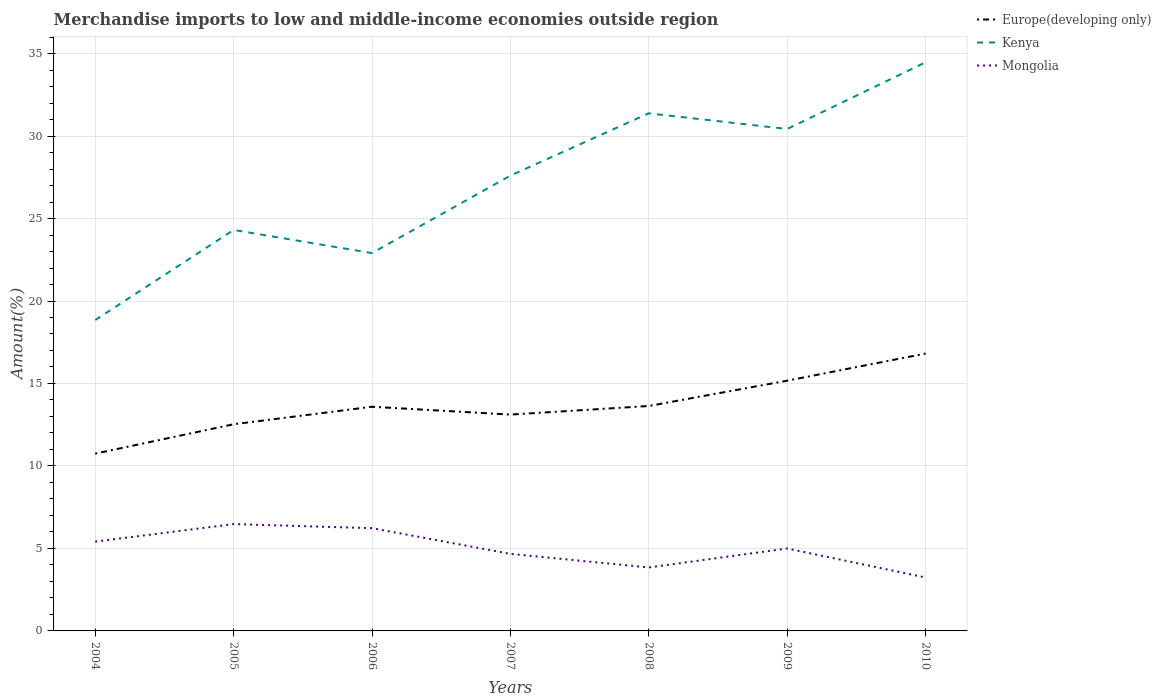How many different coloured lines are there?
Offer a very short reply. 3. Does the line corresponding to Europe(developing only) intersect with the line corresponding to Mongolia?
Keep it short and to the point. No. Is the number of lines equal to the number of legend labels?
Keep it short and to the point. Yes. Across all years, what is the maximum percentage of amount earned from merchandise imports in Europe(developing only)?
Your response must be concise. 10.75. What is the total percentage of amount earned from merchandise imports in Kenya in the graph?
Give a very brief answer. -2.83. What is the difference between the highest and the second highest percentage of amount earned from merchandise imports in Kenya?
Your answer should be very brief. 15.62. Is the percentage of amount earned from merchandise imports in Mongolia strictly greater than the percentage of amount earned from merchandise imports in Kenya over the years?
Offer a terse response. Yes. How many lines are there?
Make the answer very short. 3. How many legend labels are there?
Offer a very short reply. 3. How are the legend labels stacked?
Your answer should be very brief. Vertical. What is the title of the graph?
Offer a very short reply. Merchandise imports to low and middle-income economies outside region. What is the label or title of the X-axis?
Give a very brief answer. Years. What is the label or title of the Y-axis?
Offer a terse response. Amount(%). What is the Amount(%) of Europe(developing only) in 2004?
Your answer should be very brief. 10.75. What is the Amount(%) in Kenya in 2004?
Your response must be concise. 18.85. What is the Amount(%) of Mongolia in 2004?
Ensure brevity in your answer.  5.41. What is the Amount(%) in Europe(developing only) in 2005?
Give a very brief answer. 12.53. What is the Amount(%) of Kenya in 2005?
Your response must be concise. 24.31. What is the Amount(%) in Mongolia in 2005?
Your answer should be very brief. 6.48. What is the Amount(%) of Europe(developing only) in 2006?
Provide a short and direct response. 13.59. What is the Amount(%) of Kenya in 2006?
Give a very brief answer. 22.91. What is the Amount(%) of Mongolia in 2006?
Make the answer very short. 6.23. What is the Amount(%) in Europe(developing only) in 2007?
Offer a terse response. 13.11. What is the Amount(%) of Kenya in 2007?
Ensure brevity in your answer.  27.6. What is the Amount(%) of Mongolia in 2007?
Your answer should be very brief. 4.67. What is the Amount(%) in Europe(developing only) in 2008?
Offer a terse response. 13.64. What is the Amount(%) in Kenya in 2008?
Your response must be concise. 31.38. What is the Amount(%) in Mongolia in 2008?
Your answer should be very brief. 3.85. What is the Amount(%) in Europe(developing only) in 2009?
Give a very brief answer. 15.17. What is the Amount(%) of Kenya in 2009?
Offer a terse response. 30.43. What is the Amount(%) of Mongolia in 2009?
Give a very brief answer. 5. What is the Amount(%) in Europe(developing only) in 2010?
Provide a short and direct response. 16.81. What is the Amount(%) of Kenya in 2010?
Give a very brief answer. 34.47. What is the Amount(%) in Mongolia in 2010?
Give a very brief answer. 3.24. Across all years, what is the maximum Amount(%) of Europe(developing only)?
Make the answer very short. 16.81. Across all years, what is the maximum Amount(%) of Kenya?
Provide a succinct answer. 34.47. Across all years, what is the maximum Amount(%) of Mongolia?
Make the answer very short. 6.48. Across all years, what is the minimum Amount(%) in Europe(developing only)?
Your response must be concise. 10.75. Across all years, what is the minimum Amount(%) of Kenya?
Give a very brief answer. 18.85. Across all years, what is the minimum Amount(%) in Mongolia?
Your response must be concise. 3.24. What is the total Amount(%) of Europe(developing only) in the graph?
Provide a succinct answer. 95.6. What is the total Amount(%) in Kenya in the graph?
Keep it short and to the point. 189.93. What is the total Amount(%) of Mongolia in the graph?
Give a very brief answer. 34.88. What is the difference between the Amount(%) of Europe(developing only) in 2004 and that in 2005?
Ensure brevity in your answer.  -1.78. What is the difference between the Amount(%) in Kenya in 2004 and that in 2005?
Provide a succinct answer. -5.46. What is the difference between the Amount(%) in Mongolia in 2004 and that in 2005?
Your answer should be compact. -1.06. What is the difference between the Amount(%) of Europe(developing only) in 2004 and that in 2006?
Give a very brief answer. -2.84. What is the difference between the Amount(%) of Kenya in 2004 and that in 2006?
Give a very brief answer. -4.06. What is the difference between the Amount(%) in Mongolia in 2004 and that in 2006?
Ensure brevity in your answer.  -0.82. What is the difference between the Amount(%) of Europe(developing only) in 2004 and that in 2007?
Keep it short and to the point. -2.37. What is the difference between the Amount(%) of Kenya in 2004 and that in 2007?
Provide a succinct answer. -8.76. What is the difference between the Amount(%) in Mongolia in 2004 and that in 2007?
Your answer should be very brief. 0.74. What is the difference between the Amount(%) in Europe(developing only) in 2004 and that in 2008?
Provide a short and direct response. -2.89. What is the difference between the Amount(%) of Kenya in 2004 and that in 2008?
Your answer should be compact. -12.53. What is the difference between the Amount(%) of Mongolia in 2004 and that in 2008?
Ensure brevity in your answer.  1.57. What is the difference between the Amount(%) in Europe(developing only) in 2004 and that in 2009?
Your response must be concise. -4.42. What is the difference between the Amount(%) in Kenya in 2004 and that in 2009?
Ensure brevity in your answer.  -11.58. What is the difference between the Amount(%) in Mongolia in 2004 and that in 2009?
Keep it short and to the point. 0.42. What is the difference between the Amount(%) in Europe(developing only) in 2004 and that in 2010?
Provide a succinct answer. -6.07. What is the difference between the Amount(%) of Kenya in 2004 and that in 2010?
Offer a very short reply. -15.62. What is the difference between the Amount(%) of Mongolia in 2004 and that in 2010?
Provide a short and direct response. 2.18. What is the difference between the Amount(%) in Europe(developing only) in 2005 and that in 2006?
Make the answer very short. -1.06. What is the difference between the Amount(%) in Kenya in 2005 and that in 2006?
Offer a very short reply. 1.4. What is the difference between the Amount(%) of Mongolia in 2005 and that in 2006?
Ensure brevity in your answer.  0.25. What is the difference between the Amount(%) of Europe(developing only) in 2005 and that in 2007?
Your answer should be very brief. -0.59. What is the difference between the Amount(%) in Kenya in 2005 and that in 2007?
Give a very brief answer. -3.3. What is the difference between the Amount(%) of Mongolia in 2005 and that in 2007?
Make the answer very short. 1.81. What is the difference between the Amount(%) of Europe(developing only) in 2005 and that in 2008?
Your answer should be very brief. -1.11. What is the difference between the Amount(%) of Kenya in 2005 and that in 2008?
Provide a short and direct response. -7.07. What is the difference between the Amount(%) in Mongolia in 2005 and that in 2008?
Provide a short and direct response. 2.63. What is the difference between the Amount(%) in Europe(developing only) in 2005 and that in 2009?
Your response must be concise. -2.64. What is the difference between the Amount(%) of Kenya in 2005 and that in 2009?
Your answer should be compact. -6.12. What is the difference between the Amount(%) of Mongolia in 2005 and that in 2009?
Your answer should be compact. 1.48. What is the difference between the Amount(%) in Europe(developing only) in 2005 and that in 2010?
Make the answer very short. -4.29. What is the difference between the Amount(%) in Kenya in 2005 and that in 2010?
Ensure brevity in your answer.  -10.16. What is the difference between the Amount(%) of Mongolia in 2005 and that in 2010?
Keep it short and to the point. 3.24. What is the difference between the Amount(%) of Europe(developing only) in 2006 and that in 2007?
Provide a short and direct response. 0.47. What is the difference between the Amount(%) of Kenya in 2006 and that in 2007?
Provide a succinct answer. -4.7. What is the difference between the Amount(%) of Mongolia in 2006 and that in 2007?
Ensure brevity in your answer.  1.56. What is the difference between the Amount(%) of Europe(developing only) in 2006 and that in 2008?
Ensure brevity in your answer.  -0.05. What is the difference between the Amount(%) of Kenya in 2006 and that in 2008?
Make the answer very short. -8.47. What is the difference between the Amount(%) in Mongolia in 2006 and that in 2008?
Your answer should be compact. 2.38. What is the difference between the Amount(%) of Europe(developing only) in 2006 and that in 2009?
Your response must be concise. -1.58. What is the difference between the Amount(%) in Kenya in 2006 and that in 2009?
Offer a terse response. -7.52. What is the difference between the Amount(%) of Mongolia in 2006 and that in 2009?
Your response must be concise. 1.23. What is the difference between the Amount(%) of Europe(developing only) in 2006 and that in 2010?
Your answer should be very brief. -3.22. What is the difference between the Amount(%) in Kenya in 2006 and that in 2010?
Ensure brevity in your answer.  -11.56. What is the difference between the Amount(%) in Mongolia in 2006 and that in 2010?
Provide a short and direct response. 2.99. What is the difference between the Amount(%) of Europe(developing only) in 2007 and that in 2008?
Offer a terse response. -0.52. What is the difference between the Amount(%) of Kenya in 2007 and that in 2008?
Your answer should be very brief. -3.78. What is the difference between the Amount(%) of Mongolia in 2007 and that in 2008?
Provide a succinct answer. 0.82. What is the difference between the Amount(%) of Europe(developing only) in 2007 and that in 2009?
Give a very brief answer. -2.06. What is the difference between the Amount(%) of Kenya in 2007 and that in 2009?
Your answer should be very brief. -2.83. What is the difference between the Amount(%) of Mongolia in 2007 and that in 2009?
Your answer should be very brief. -0.33. What is the difference between the Amount(%) of Europe(developing only) in 2007 and that in 2010?
Offer a very short reply. -3.7. What is the difference between the Amount(%) in Kenya in 2007 and that in 2010?
Give a very brief answer. -6.87. What is the difference between the Amount(%) of Mongolia in 2007 and that in 2010?
Your response must be concise. 1.43. What is the difference between the Amount(%) in Europe(developing only) in 2008 and that in 2009?
Offer a terse response. -1.53. What is the difference between the Amount(%) in Kenya in 2008 and that in 2009?
Offer a terse response. 0.95. What is the difference between the Amount(%) of Mongolia in 2008 and that in 2009?
Ensure brevity in your answer.  -1.15. What is the difference between the Amount(%) in Europe(developing only) in 2008 and that in 2010?
Give a very brief answer. -3.18. What is the difference between the Amount(%) of Kenya in 2008 and that in 2010?
Your answer should be compact. -3.09. What is the difference between the Amount(%) of Mongolia in 2008 and that in 2010?
Offer a terse response. 0.61. What is the difference between the Amount(%) of Europe(developing only) in 2009 and that in 2010?
Ensure brevity in your answer.  -1.64. What is the difference between the Amount(%) in Kenya in 2009 and that in 2010?
Your answer should be very brief. -4.04. What is the difference between the Amount(%) of Mongolia in 2009 and that in 2010?
Keep it short and to the point. 1.76. What is the difference between the Amount(%) of Europe(developing only) in 2004 and the Amount(%) of Kenya in 2005?
Ensure brevity in your answer.  -13.56. What is the difference between the Amount(%) in Europe(developing only) in 2004 and the Amount(%) in Mongolia in 2005?
Your answer should be compact. 4.27. What is the difference between the Amount(%) in Kenya in 2004 and the Amount(%) in Mongolia in 2005?
Provide a short and direct response. 12.37. What is the difference between the Amount(%) of Europe(developing only) in 2004 and the Amount(%) of Kenya in 2006?
Provide a succinct answer. -12.16. What is the difference between the Amount(%) in Europe(developing only) in 2004 and the Amount(%) in Mongolia in 2006?
Offer a terse response. 4.52. What is the difference between the Amount(%) of Kenya in 2004 and the Amount(%) of Mongolia in 2006?
Your answer should be compact. 12.62. What is the difference between the Amount(%) in Europe(developing only) in 2004 and the Amount(%) in Kenya in 2007?
Offer a terse response. -16.85. What is the difference between the Amount(%) of Europe(developing only) in 2004 and the Amount(%) of Mongolia in 2007?
Your response must be concise. 6.08. What is the difference between the Amount(%) of Kenya in 2004 and the Amount(%) of Mongolia in 2007?
Provide a succinct answer. 14.17. What is the difference between the Amount(%) in Europe(developing only) in 2004 and the Amount(%) in Kenya in 2008?
Make the answer very short. -20.63. What is the difference between the Amount(%) of Europe(developing only) in 2004 and the Amount(%) of Mongolia in 2008?
Your answer should be compact. 6.9. What is the difference between the Amount(%) in Kenya in 2004 and the Amount(%) in Mongolia in 2008?
Keep it short and to the point. 15. What is the difference between the Amount(%) of Europe(developing only) in 2004 and the Amount(%) of Kenya in 2009?
Keep it short and to the point. -19.68. What is the difference between the Amount(%) of Europe(developing only) in 2004 and the Amount(%) of Mongolia in 2009?
Keep it short and to the point. 5.75. What is the difference between the Amount(%) of Kenya in 2004 and the Amount(%) of Mongolia in 2009?
Keep it short and to the point. 13.85. What is the difference between the Amount(%) in Europe(developing only) in 2004 and the Amount(%) in Kenya in 2010?
Your answer should be compact. -23.72. What is the difference between the Amount(%) in Europe(developing only) in 2004 and the Amount(%) in Mongolia in 2010?
Keep it short and to the point. 7.51. What is the difference between the Amount(%) of Kenya in 2004 and the Amount(%) of Mongolia in 2010?
Offer a very short reply. 15.61. What is the difference between the Amount(%) in Europe(developing only) in 2005 and the Amount(%) in Kenya in 2006?
Offer a very short reply. -10.38. What is the difference between the Amount(%) of Europe(developing only) in 2005 and the Amount(%) of Mongolia in 2006?
Your answer should be very brief. 6.3. What is the difference between the Amount(%) in Kenya in 2005 and the Amount(%) in Mongolia in 2006?
Keep it short and to the point. 18.08. What is the difference between the Amount(%) in Europe(developing only) in 2005 and the Amount(%) in Kenya in 2007?
Offer a very short reply. -15.07. What is the difference between the Amount(%) in Europe(developing only) in 2005 and the Amount(%) in Mongolia in 2007?
Make the answer very short. 7.86. What is the difference between the Amount(%) in Kenya in 2005 and the Amount(%) in Mongolia in 2007?
Provide a short and direct response. 19.64. What is the difference between the Amount(%) in Europe(developing only) in 2005 and the Amount(%) in Kenya in 2008?
Give a very brief answer. -18.85. What is the difference between the Amount(%) in Europe(developing only) in 2005 and the Amount(%) in Mongolia in 2008?
Your response must be concise. 8.68. What is the difference between the Amount(%) in Kenya in 2005 and the Amount(%) in Mongolia in 2008?
Your answer should be very brief. 20.46. What is the difference between the Amount(%) in Europe(developing only) in 2005 and the Amount(%) in Kenya in 2009?
Your answer should be compact. -17.9. What is the difference between the Amount(%) of Europe(developing only) in 2005 and the Amount(%) of Mongolia in 2009?
Your answer should be compact. 7.53. What is the difference between the Amount(%) in Kenya in 2005 and the Amount(%) in Mongolia in 2009?
Provide a short and direct response. 19.31. What is the difference between the Amount(%) in Europe(developing only) in 2005 and the Amount(%) in Kenya in 2010?
Provide a short and direct response. -21.94. What is the difference between the Amount(%) of Europe(developing only) in 2005 and the Amount(%) of Mongolia in 2010?
Keep it short and to the point. 9.29. What is the difference between the Amount(%) in Kenya in 2005 and the Amount(%) in Mongolia in 2010?
Your response must be concise. 21.07. What is the difference between the Amount(%) in Europe(developing only) in 2006 and the Amount(%) in Kenya in 2007?
Give a very brief answer. -14.01. What is the difference between the Amount(%) of Europe(developing only) in 2006 and the Amount(%) of Mongolia in 2007?
Offer a terse response. 8.92. What is the difference between the Amount(%) in Kenya in 2006 and the Amount(%) in Mongolia in 2007?
Your answer should be compact. 18.23. What is the difference between the Amount(%) in Europe(developing only) in 2006 and the Amount(%) in Kenya in 2008?
Keep it short and to the point. -17.79. What is the difference between the Amount(%) of Europe(developing only) in 2006 and the Amount(%) of Mongolia in 2008?
Your answer should be compact. 9.74. What is the difference between the Amount(%) of Kenya in 2006 and the Amount(%) of Mongolia in 2008?
Provide a succinct answer. 19.06. What is the difference between the Amount(%) in Europe(developing only) in 2006 and the Amount(%) in Kenya in 2009?
Provide a short and direct response. -16.84. What is the difference between the Amount(%) in Europe(developing only) in 2006 and the Amount(%) in Mongolia in 2009?
Your answer should be very brief. 8.59. What is the difference between the Amount(%) in Kenya in 2006 and the Amount(%) in Mongolia in 2009?
Offer a very short reply. 17.91. What is the difference between the Amount(%) of Europe(developing only) in 2006 and the Amount(%) of Kenya in 2010?
Give a very brief answer. -20.88. What is the difference between the Amount(%) in Europe(developing only) in 2006 and the Amount(%) in Mongolia in 2010?
Provide a short and direct response. 10.35. What is the difference between the Amount(%) of Kenya in 2006 and the Amount(%) of Mongolia in 2010?
Provide a short and direct response. 19.67. What is the difference between the Amount(%) in Europe(developing only) in 2007 and the Amount(%) in Kenya in 2008?
Offer a terse response. -18.26. What is the difference between the Amount(%) in Europe(developing only) in 2007 and the Amount(%) in Mongolia in 2008?
Offer a terse response. 9.27. What is the difference between the Amount(%) in Kenya in 2007 and the Amount(%) in Mongolia in 2008?
Offer a very short reply. 23.76. What is the difference between the Amount(%) of Europe(developing only) in 2007 and the Amount(%) of Kenya in 2009?
Keep it short and to the point. -17.31. What is the difference between the Amount(%) of Europe(developing only) in 2007 and the Amount(%) of Mongolia in 2009?
Keep it short and to the point. 8.12. What is the difference between the Amount(%) of Kenya in 2007 and the Amount(%) of Mongolia in 2009?
Make the answer very short. 22.6. What is the difference between the Amount(%) in Europe(developing only) in 2007 and the Amount(%) in Kenya in 2010?
Your answer should be compact. -21.35. What is the difference between the Amount(%) of Europe(developing only) in 2007 and the Amount(%) of Mongolia in 2010?
Your answer should be compact. 9.88. What is the difference between the Amount(%) in Kenya in 2007 and the Amount(%) in Mongolia in 2010?
Offer a very short reply. 24.36. What is the difference between the Amount(%) in Europe(developing only) in 2008 and the Amount(%) in Kenya in 2009?
Offer a very short reply. -16.79. What is the difference between the Amount(%) in Europe(developing only) in 2008 and the Amount(%) in Mongolia in 2009?
Your answer should be very brief. 8.64. What is the difference between the Amount(%) of Kenya in 2008 and the Amount(%) of Mongolia in 2009?
Make the answer very short. 26.38. What is the difference between the Amount(%) of Europe(developing only) in 2008 and the Amount(%) of Kenya in 2010?
Provide a short and direct response. -20.83. What is the difference between the Amount(%) in Europe(developing only) in 2008 and the Amount(%) in Mongolia in 2010?
Provide a short and direct response. 10.4. What is the difference between the Amount(%) of Kenya in 2008 and the Amount(%) of Mongolia in 2010?
Offer a terse response. 28.14. What is the difference between the Amount(%) of Europe(developing only) in 2009 and the Amount(%) of Kenya in 2010?
Provide a succinct answer. -19.3. What is the difference between the Amount(%) in Europe(developing only) in 2009 and the Amount(%) in Mongolia in 2010?
Ensure brevity in your answer.  11.93. What is the difference between the Amount(%) of Kenya in 2009 and the Amount(%) of Mongolia in 2010?
Provide a succinct answer. 27.19. What is the average Amount(%) of Europe(developing only) per year?
Offer a terse response. 13.66. What is the average Amount(%) of Kenya per year?
Offer a very short reply. 27.13. What is the average Amount(%) of Mongolia per year?
Offer a terse response. 4.98. In the year 2004, what is the difference between the Amount(%) in Europe(developing only) and Amount(%) in Kenya?
Your response must be concise. -8.1. In the year 2004, what is the difference between the Amount(%) in Europe(developing only) and Amount(%) in Mongolia?
Provide a short and direct response. 5.33. In the year 2004, what is the difference between the Amount(%) in Kenya and Amount(%) in Mongolia?
Ensure brevity in your answer.  13.43. In the year 2005, what is the difference between the Amount(%) in Europe(developing only) and Amount(%) in Kenya?
Make the answer very short. -11.78. In the year 2005, what is the difference between the Amount(%) in Europe(developing only) and Amount(%) in Mongolia?
Keep it short and to the point. 6.05. In the year 2005, what is the difference between the Amount(%) of Kenya and Amount(%) of Mongolia?
Your response must be concise. 17.83. In the year 2006, what is the difference between the Amount(%) in Europe(developing only) and Amount(%) in Kenya?
Offer a very short reply. -9.32. In the year 2006, what is the difference between the Amount(%) in Europe(developing only) and Amount(%) in Mongolia?
Provide a short and direct response. 7.36. In the year 2006, what is the difference between the Amount(%) in Kenya and Amount(%) in Mongolia?
Your response must be concise. 16.68. In the year 2007, what is the difference between the Amount(%) in Europe(developing only) and Amount(%) in Kenya?
Make the answer very short. -14.49. In the year 2007, what is the difference between the Amount(%) of Europe(developing only) and Amount(%) of Mongolia?
Keep it short and to the point. 8.44. In the year 2007, what is the difference between the Amount(%) of Kenya and Amount(%) of Mongolia?
Your answer should be very brief. 22.93. In the year 2008, what is the difference between the Amount(%) of Europe(developing only) and Amount(%) of Kenya?
Make the answer very short. -17.74. In the year 2008, what is the difference between the Amount(%) of Europe(developing only) and Amount(%) of Mongolia?
Your answer should be very brief. 9.79. In the year 2008, what is the difference between the Amount(%) in Kenya and Amount(%) in Mongolia?
Your answer should be very brief. 27.53. In the year 2009, what is the difference between the Amount(%) in Europe(developing only) and Amount(%) in Kenya?
Your response must be concise. -15.26. In the year 2009, what is the difference between the Amount(%) of Europe(developing only) and Amount(%) of Mongolia?
Offer a very short reply. 10.17. In the year 2009, what is the difference between the Amount(%) in Kenya and Amount(%) in Mongolia?
Provide a short and direct response. 25.43. In the year 2010, what is the difference between the Amount(%) of Europe(developing only) and Amount(%) of Kenya?
Your answer should be very brief. -17.65. In the year 2010, what is the difference between the Amount(%) of Europe(developing only) and Amount(%) of Mongolia?
Your answer should be very brief. 13.57. In the year 2010, what is the difference between the Amount(%) of Kenya and Amount(%) of Mongolia?
Offer a very short reply. 31.23. What is the ratio of the Amount(%) in Europe(developing only) in 2004 to that in 2005?
Ensure brevity in your answer.  0.86. What is the ratio of the Amount(%) in Kenya in 2004 to that in 2005?
Your response must be concise. 0.78. What is the ratio of the Amount(%) of Mongolia in 2004 to that in 2005?
Your answer should be compact. 0.84. What is the ratio of the Amount(%) in Europe(developing only) in 2004 to that in 2006?
Give a very brief answer. 0.79. What is the ratio of the Amount(%) in Kenya in 2004 to that in 2006?
Your answer should be very brief. 0.82. What is the ratio of the Amount(%) of Mongolia in 2004 to that in 2006?
Ensure brevity in your answer.  0.87. What is the ratio of the Amount(%) of Europe(developing only) in 2004 to that in 2007?
Offer a very short reply. 0.82. What is the ratio of the Amount(%) of Kenya in 2004 to that in 2007?
Keep it short and to the point. 0.68. What is the ratio of the Amount(%) of Mongolia in 2004 to that in 2007?
Your response must be concise. 1.16. What is the ratio of the Amount(%) of Europe(developing only) in 2004 to that in 2008?
Your answer should be very brief. 0.79. What is the ratio of the Amount(%) in Kenya in 2004 to that in 2008?
Your answer should be very brief. 0.6. What is the ratio of the Amount(%) in Mongolia in 2004 to that in 2008?
Your answer should be very brief. 1.41. What is the ratio of the Amount(%) in Europe(developing only) in 2004 to that in 2009?
Your response must be concise. 0.71. What is the ratio of the Amount(%) of Kenya in 2004 to that in 2009?
Provide a short and direct response. 0.62. What is the ratio of the Amount(%) of Mongolia in 2004 to that in 2009?
Provide a short and direct response. 1.08. What is the ratio of the Amount(%) of Europe(developing only) in 2004 to that in 2010?
Provide a succinct answer. 0.64. What is the ratio of the Amount(%) in Kenya in 2004 to that in 2010?
Give a very brief answer. 0.55. What is the ratio of the Amount(%) in Mongolia in 2004 to that in 2010?
Provide a short and direct response. 1.67. What is the ratio of the Amount(%) of Europe(developing only) in 2005 to that in 2006?
Give a very brief answer. 0.92. What is the ratio of the Amount(%) of Kenya in 2005 to that in 2006?
Make the answer very short. 1.06. What is the ratio of the Amount(%) in Mongolia in 2005 to that in 2006?
Your answer should be compact. 1.04. What is the ratio of the Amount(%) of Europe(developing only) in 2005 to that in 2007?
Provide a short and direct response. 0.96. What is the ratio of the Amount(%) in Kenya in 2005 to that in 2007?
Ensure brevity in your answer.  0.88. What is the ratio of the Amount(%) of Mongolia in 2005 to that in 2007?
Your answer should be very brief. 1.39. What is the ratio of the Amount(%) of Europe(developing only) in 2005 to that in 2008?
Make the answer very short. 0.92. What is the ratio of the Amount(%) in Kenya in 2005 to that in 2008?
Give a very brief answer. 0.77. What is the ratio of the Amount(%) in Mongolia in 2005 to that in 2008?
Your answer should be compact. 1.68. What is the ratio of the Amount(%) in Europe(developing only) in 2005 to that in 2009?
Offer a very short reply. 0.83. What is the ratio of the Amount(%) of Kenya in 2005 to that in 2009?
Ensure brevity in your answer.  0.8. What is the ratio of the Amount(%) in Mongolia in 2005 to that in 2009?
Offer a very short reply. 1.3. What is the ratio of the Amount(%) in Europe(developing only) in 2005 to that in 2010?
Offer a terse response. 0.75. What is the ratio of the Amount(%) of Kenya in 2005 to that in 2010?
Provide a succinct answer. 0.71. What is the ratio of the Amount(%) of Mongolia in 2005 to that in 2010?
Provide a short and direct response. 2. What is the ratio of the Amount(%) of Europe(developing only) in 2006 to that in 2007?
Your response must be concise. 1.04. What is the ratio of the Amount(%) of Kenya in 2006 to that in 2007?
Make the answer very short. 0.83. What is the ratio of the Amount(%) of Mongolia in 2006 to that in 2007?
Provide a succinct answer. 1.33. What is the ratio of the Amount(%) of Europe(developing only) in 2006 to that in 2008?
Ensure brevity in your answer.  1. What is the ratio of the Amount(%) in Kenya in 2006 to that in 2008?
Your answer should be compact. 0.73. What is the ratio of the Amount(%) in Mongolia in 2006 to that in 2008?
Keep it short and to the point. 1.62. What is the ratio of the Amount(%) of Europe(developing only) in 2006 to that in 2009?
Make the answer very short. 0.9. What is the ratio of the Amount(%) of Kenya in 2006 to that in 2009?
Make the answer very short. 0.75. What is the ratio of the Amount(%) of Mongolia in 2006 to that in 2009?
Keep it short and to the point. 1.25. What is the ratio of the Amount(%) of Europe(developing only) in 2006 to that in 2010?
Offer a terse response. 0.81. What is the ratio of the Amount(%) in Kenya in 2006 to that in 2010?
Make the answer very short. 0.66. What is the ratio of the Amount(%) of Mongolia in 2006 to that in 2010?
Offer a very short reply. 1.92. What is the ratio of the Amount(%) in Europe(developing only) in 2007 to that in 2008?
Your answer should be very brief. 0.96. What is the ratio of the Amount(%) in Kenya in 2007 to that in 2008?
Give a very brief answer. 0.88. What is the ratio of the Amount(%) of Mongolia in 2007 to that in 2008?
Make the answer very short. 1.21. What is the ratio of the Amount(%) of Europe(developing only) in 2007 to that in 2009?
Provide a short and direct response. 0.86. What is the ratio of the Amount(%) in Kenya in 2007 to that in 2009?
Your response must be concise. 0.91. What is the ratio of the Amount(%) in Mongolia in 2007 to that in 2009?
Ensure brevity in your answer.  0.93. What is the ratio of the Amount(%) in Europe(developing only) in 2007 to that in 2010?
Give a very brief answer. 0.78. What is the ratio of the Amount(%) of Kenya in 2007 to that in 2010?
Provide a short and direct response. 0.8. What is the ratio of the Amount(%) in Mongolia in 2007 to that in 2010?
Offer a terse response. 1.44. What is the ratio of the Amount(%) of Europe(developing only) in 2008 to that in 2009?
Offer a terse response. 0.9. What is the ratio of the Amount(%) in Kenya in 2008 to that in 2009?
Provide a short and direct response. 1.03. What is the ratio of the Amount(%) of Mongolia in 2008 to that in 2009?
Provide a succinct answer. 0.77. What is the ratio of the Amount(%) in Europe(developing only) in 2008 to that in 2010?
Your answer should be compact. 0.81. What is the ratio of the Amount(%) of Kenya in 2008 to that in 2010?
Make the answer very short. 0.91. What is the ratio of the Amount(%) of Mongolia in 2008 to that in 2010?
Your answer should be very brief. 1.19. What is the ratio of the Amount(%) in Europe(developing only) in 2009 to that in 2010?
Your response must be concise. 0.9. What is the ratio of the Amount(%) of Kenya in 2009 to that in 2010?
Provide a succinct answer. 0.88. What is the ratio of the Amount(%) in Mongolia in 2009 to that in 2010?
Provide a short and direct response. 1.54. What is the difference between the highest and the second highest Amount(%) in Europe(developing only)?
Provide a short and direct response. 1.64. What is the difference between the highest and the second highest Amount(%) of Kenya?
Give a very brief answer. 3.09. What is the difference between the highest and the second highest Amount(%) of Mongolia?
Offer a very short reply. 0.25. What is the difference between the highest and the lowest Amount(%) in Europe(developing only)?
Your answer should be compact. 6.07. What is the difference between the highest and the lowest Amount(%) in Kenya?
Give a very brief answer. 15.62. What is the difference between the highest and the lowest Amount(%) of Mongolia?
Your answer should be compact. 3.24. 